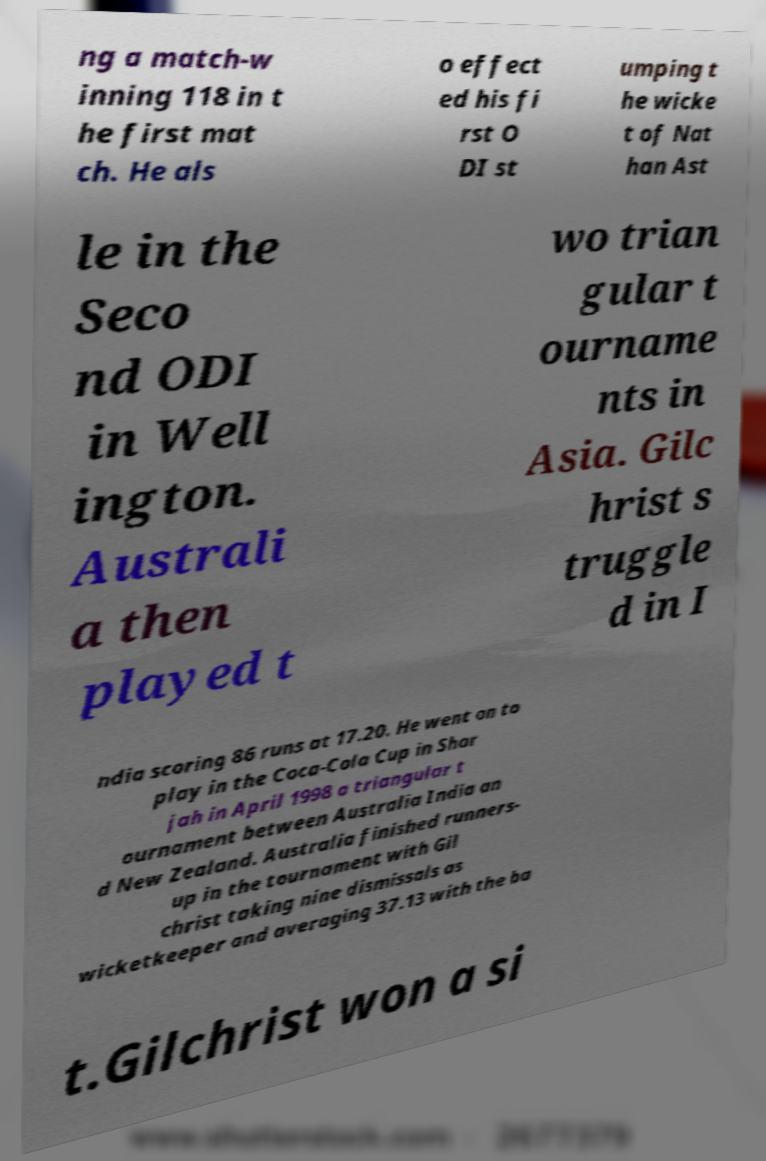Can you read and provide the text displayed in the image?This photo seems to have some interesting text. Can you extract and type it out for me? ng a match-w inning 118 in t he first mat ch. He als o effect ed his fi rst O DI st umping t he wicke t of Nat han Ast le in the Seco nd ODI in Well ington. Australi a then played t wo trian gular t ourname nts in Asia. Gilc hrist s truggle d in I ndia scoring 86 runs at 17.20. He went on to play in the Coca-Cola Cup in Shar jah in April 1998 a triangular t ournament between Australia India an d New Zealand. Australia finished runners- up in the tournament with Gil christ taking nine dismissals as wicketkeeper and averaging 37.13 with the ba t.Gilchrist won a si 